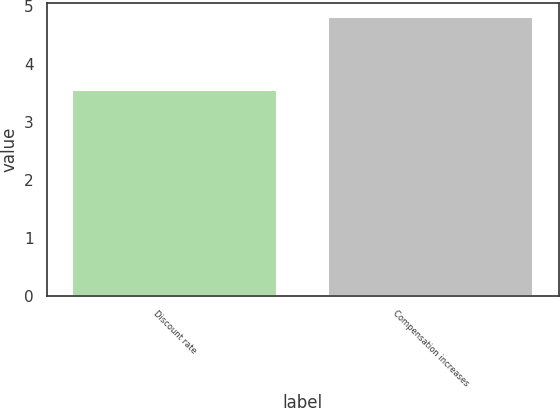Convert chart to OTSL. <chart><loc_0><loc_0><loc_500><loc_500><bar_chart><fcel>Discount rate<fcel>Compensation increases<nl><fcel>3.55<fcel>4.81<nl></chart> 